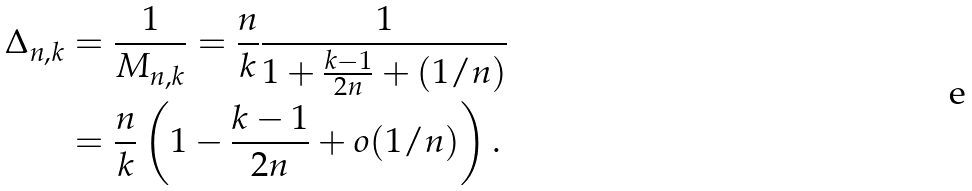Convert formula to latex. <formula><loc_0><loc_0><loc_500><loc_500>\Delta _ { n , k } & = \frac { 1 } { M _ { n , k } } = \frac { n } { k } \frac { 1 } { 1 + \frac { k - 1 } { 2 n } + ( 1 / n ) } \\ & = \frac { n } { k } \left ( 1 - \frac { k - 1 } { 2 n } + o ( 1 / n ) \right ) .</formula> 